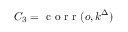Convert formula to latex. <formula><loc_0><loc_0><loc_500><loc_500>C _ { 3 } = c o r r ( o , k ^ { \Delta } )</formula> 